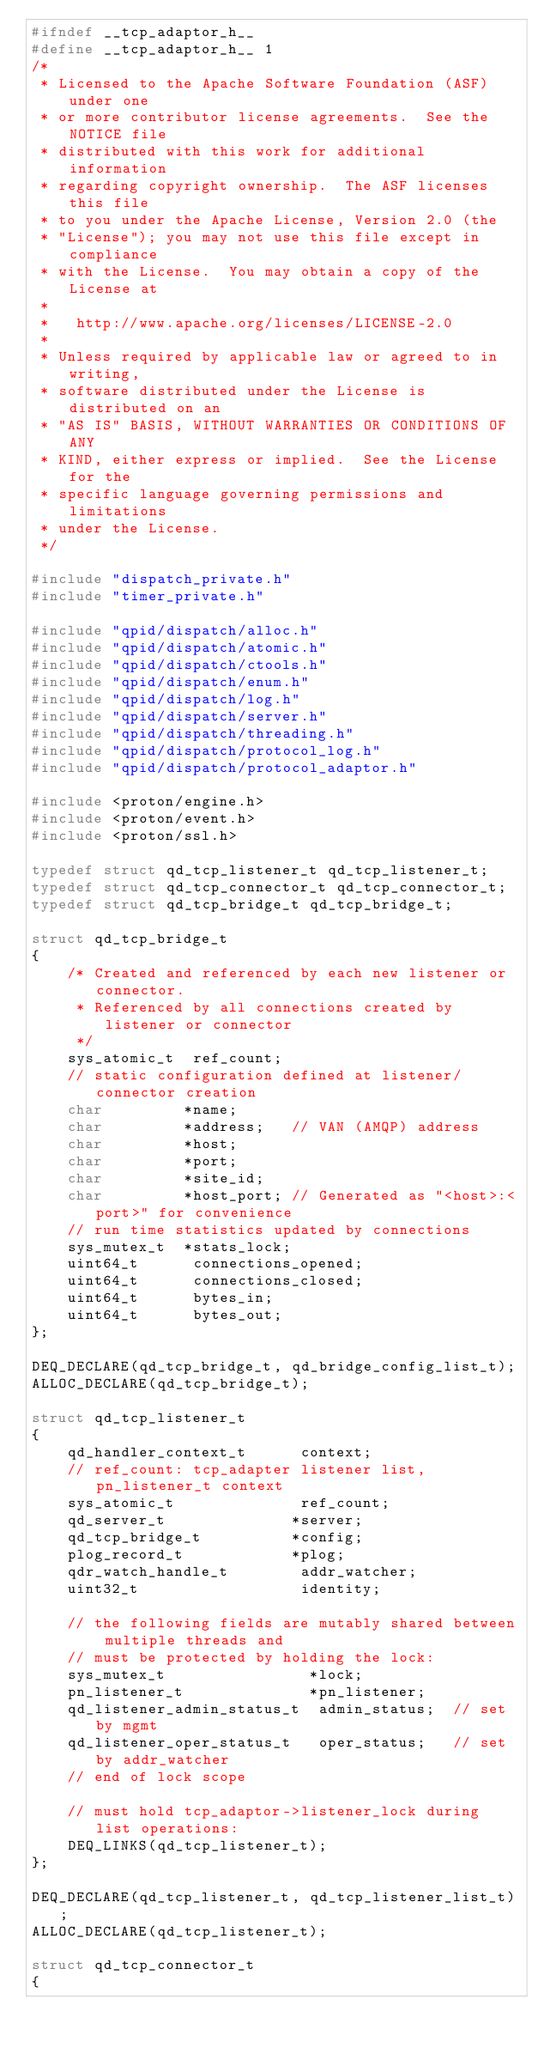Convert code to text. <code><loc_0><loc_0><loc_500><loc_500><_C_>#ifndef __tcp_adaptor_h__
#define __tcp_adaptor_h__ 1
/*
 * Licensed to the Apache Software Foundation (ASF) under one
 * or more contributor license agreements.  See the NOTICE file
 * distributed with this work for additional information
 * regarding copyright ownership.  The ASF licenses this file
 * to you under the Apache License, Version 2.0 (the
 * "License"); you may not use this file except in compliance
 * with the License.  You may obtain a copy of the License at
 *
 *   http://www.apache.org/licenses/LICENSE-2.0
 *
 * Unless required by applicable law or agreed to in writing,
 * software distributed under the License is distributed on an
 * "AS IS" BASIS, WITHOUT WARRANTIES OR CONDITIONS OF ANY
 * KIND, either express or implied.  See the License for the
 * specific language governing permissions and limitations
 * under the License.
 */

#include "dispatch_private.h"
#include "timer_private.h"

#include "qpid/dispatch/alloc.h"
#include "qpid/dispatch/atomic.h"
#include "qpid/dispatch/ctools.h"
#include "qpid/dispatch/enum.h"
#include "qpid/dispatch/log.h"
#include "qpid/dispatch/server.h"
#include "qpid/dispatch/threading.h"
#include "qpid/dispatch/protocol_log.h"
#include "qpid/dispatch/protocol_adaptor.h"

#include <proton/engine.h>
#include <proton/event.h>
#include <proton/ssl.h>

typedef struct qd_tcp_listener_t qd_tcp_listener_t;
typedef struct qd_tcp_connector_t qd_tcp_connector_t;
typedef struct qd_tcp_bridge_t qd_tcp_bridge_t;

struct qd_tcp_bridge_t
{
    /* Created and referenced by each new listener or connector.
     * Referenced by all connections created by listener or connector
     */
    sys_atomic_t  ref_count;
    // static configuration defined at listener/connector creation
    char         *name;
    char         *address;   // VAN (AMQP) address
    char         *host;
    char         *port;
    char         *site_id;
    char         *host_port; // Generated as "<host>:<port>" for convenience
    // run time statistics updated by connections
    sys_mutex_t  *stats_lock;
    uint64_t      connections_opened;
    uint64_t      connections_closed;
    uint64_t      bytes_in;
    uint64_t      bytes_out;
};

DEQ_DECLARE(qd_tcp_bridge_t, qd_bridge_config_list_t);
ALLOC_DECLARE(qd_tcp_bridge_t);

struct qd_tcp_listener_t
{
    qd_handler_context_t      context;
    // ref_count: tcp_adapter listener list, pn_listener_t context
    sys_atomic_t              ref_count;
    qd_server_t              *server;
    qd_tcp_bridge_t          *config;
    plog_record_t            *plog;
    qdr_watch_handle_t        addr_watcher;
    uint32_t                  identity;

    // the following fields are mutably shared between multiple threads and
    // must be protected by holding the lock:
    sys_mutex_t                *lock;
    pn_listener_t              *pn_listener;
    qd_listener_admin_status_t  admin_status;  // set by mgmt
    qd_listener_oper_status_t   oper_status;   // set by addr_watcher
    // end of lock scope

    // must hold tcp_adaptor->listener_lock during list operations:
    DEQ_LINKS(qd_tcp_listener_t);
};

DEQ_DECLARE(qd_tcp_listener_t, qd_tcp_listener_list_t);
ALLOC_DECLARE(qd_tcp_listener_t);

struct qd_tcp_connector_t
{</code> 